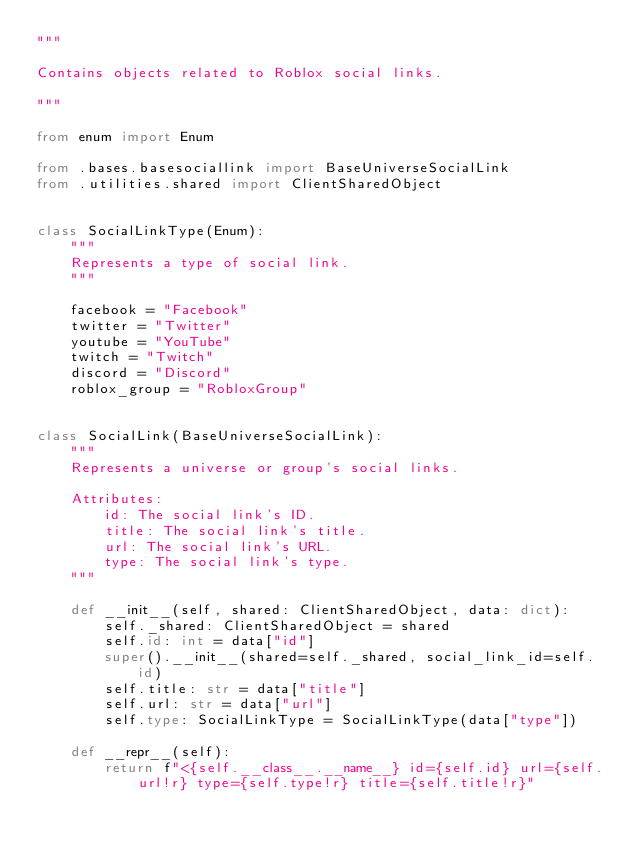Convert code to text. <code><loc_0><loc_0><loc_500><loc_500><_Python_>"""

Contains objects related to Roblox social links.

"""

from enum import Enum

from .bases.basesociallink import BaseUniverseSocialLink
from .utilities.shared import ClientSharedObject


class SocialLinkType(Enum):
    """
    Represents a type of social link.
    """

    facebook = "Facebook"
    twitter = "Twitter"
    youtube = "YouTube"
    twitch = "Twitch"
    discord = "Discord"
    roblox_group = "RobloxGroup"


class SocialLink(BaseUniverseSocialLink):
    """
    Represents a universe or group's social links.

    Attributes:
        id: The social link's ID.
        title: The social link's title.
        url: The social link's URL.
        type: The social link's type.
    """

    def __init__(self, shared: ClientSharedObject, data: dict):
        self._shared: ClientSharedObject = shared
        self.id: int = data["id"]
        super().__init__(shared=self._shared, social_link_id=self.id)
        self.title: str = data["title"]
        self.url: str = data["url"]
        self.type: SocialLinkType = SocialLinkType(data["type"])

    def __repr__(self):
        return f"<{self.__class__.__name__} id={self.id} url={self.url!r} type={self.type!r} title={self.title!r}"
</code> 